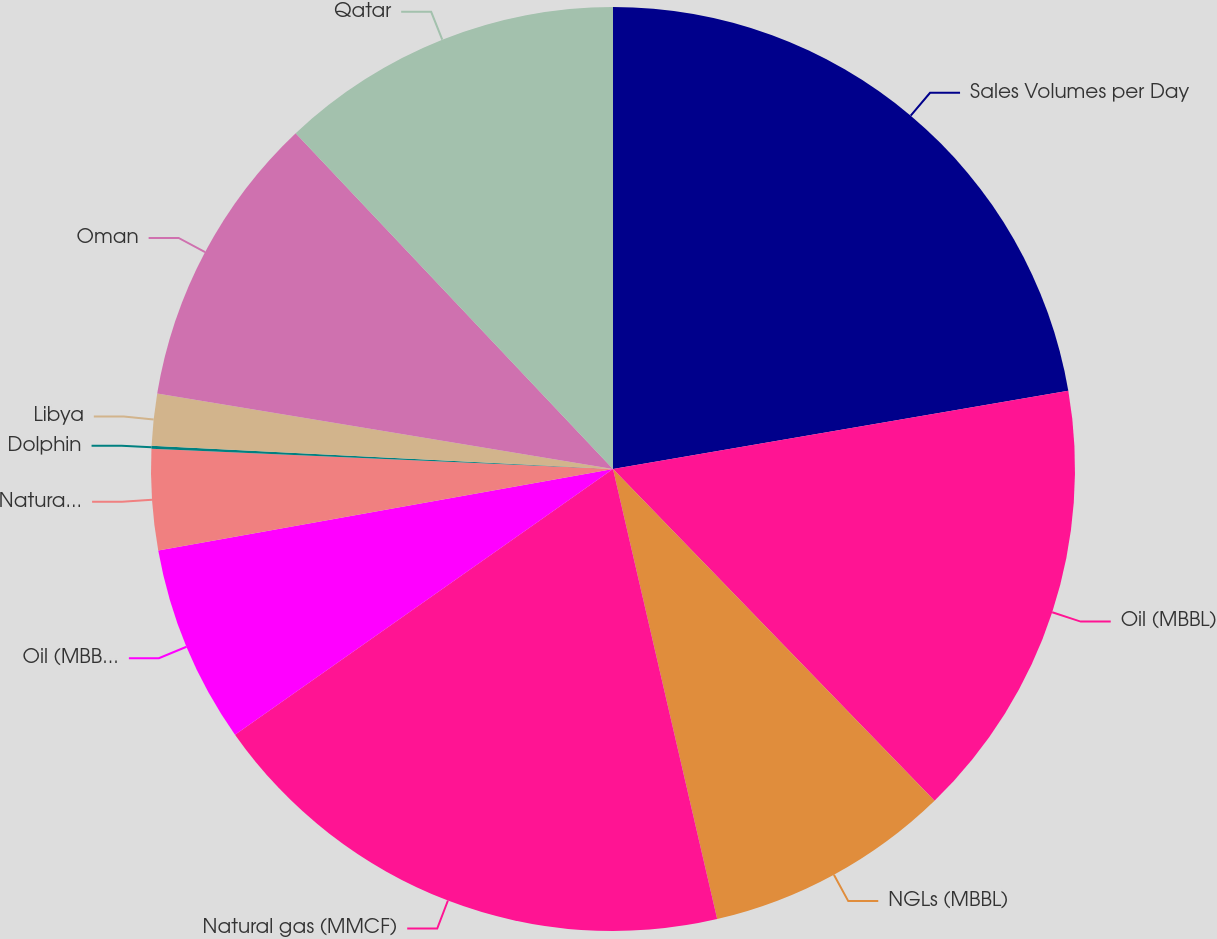Convert chart to OTSL. <chart><loc_0><loc_0><loc_500><loc_500><pie_chart><fcel>Sales Volumes per Day<fcel>Oil (MBBL)<fcel>NGLs (MBBL)<fcel>Natural gas (MMCF)<fcel>Oil (MBBL) - Colombia (b)<fcel>Natural gas (MMCF) - Bolivia<fcel>Dolphin<fcel>Libya<fcel>Oman<fcel>Qatar<nl><fcel>22.29%<fcel>15.46%<fcel>8.63%<fcel>18.87%<fcel>6.93%<fcel>3.52%<fcel>0.1%<fcel>1.81%<fcel>10.34%<fcel>12.05%<nl></chart> 